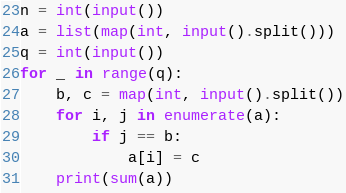Convert code to text. <code><loc_0><loc_0><loc_500><loc_500><_Python_>n = int(input())
a = list(map(int, input().split()))
q = int(input())
for _ in range(q):
    b, c = map(int, input().split())
    for i, j in enumerate(a):
        if j == b:
            a[i] = c
    print(sum(a))</code> 